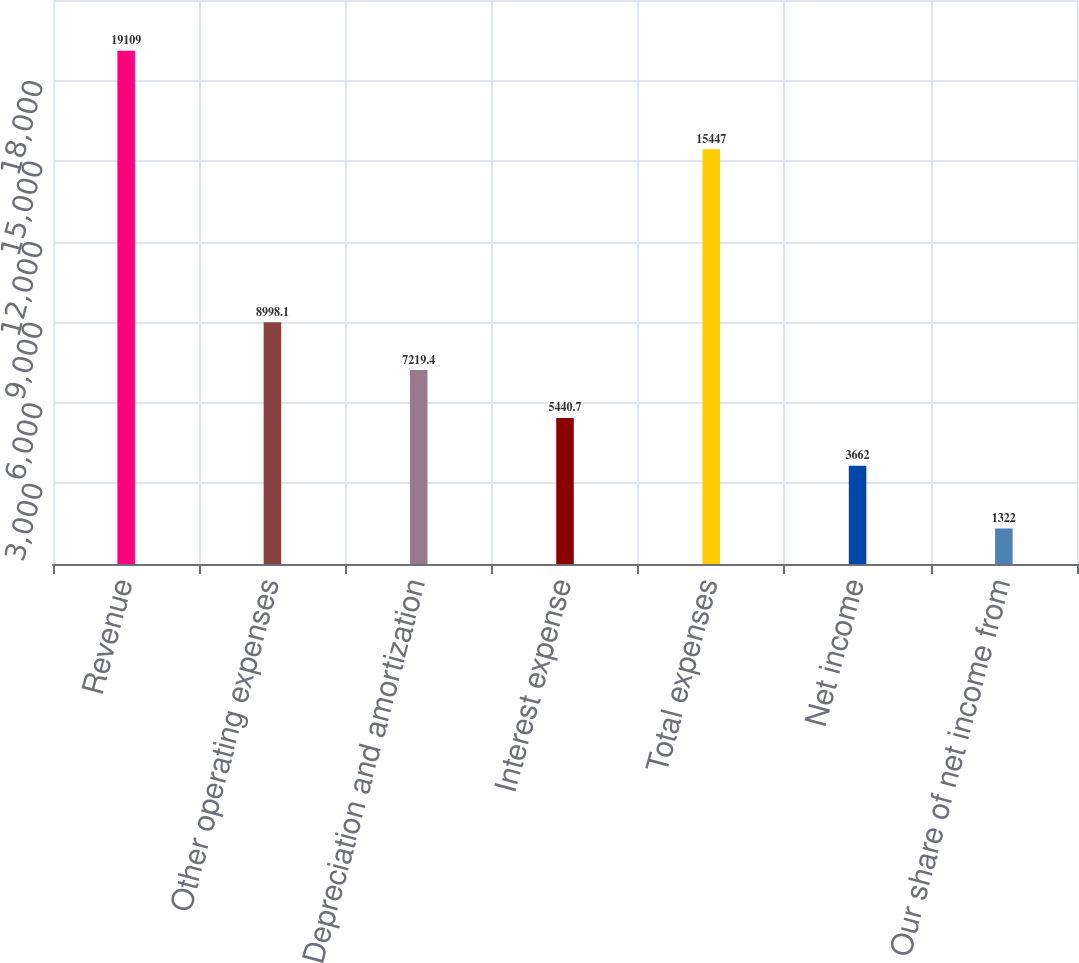<chart> <loc_0><loc_0><loc_500><loc_500><bar_chart><fcel>Revenue<fcel>Other operating expenses<fcel>Depreciation and amortization<fcel>Interest expense<fcel>Total expenses<fcel>Net income<fcel>Our share of net income from<nl><fcel>19109<fcel>8998.1<fcel>7219.4<fcel>5440.7<fcel>15447<fcel>3662<fcel>1322<nl></chart> 